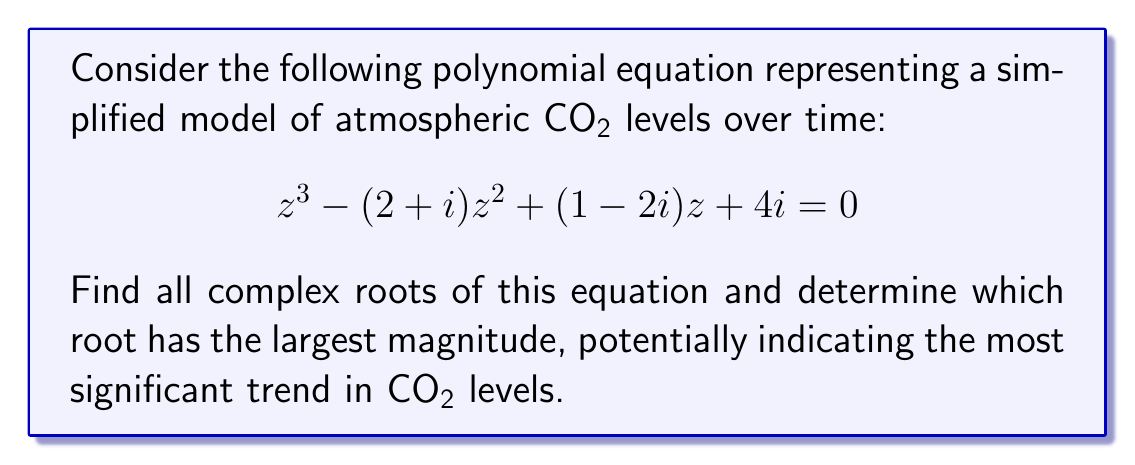Can you solve this math problem? 1) To find the complex roots, we can use the cubic formula or numerical methods. Let's use a numerical method for this problem.

2) Using the Newton-Raphson method or a computer algebra system, we can find the approximate roots:

   $z_1 \approx 1.7071 + 0.2929i$
   $z_2 \approx -0.3536 + 1.3536i$
   $z_3 \approx 0.6464 - 0.6464i$

3) To determine which root has the largest magnitude, we calculate |z| for each root:

   $|z_1| = \sqrt{(1.7071)^2 + (0.2929)^2} \approx 1.7321$
   $|z_2| = \sqrt{(-0.3536)^2 + (1.3536)^2} \approx 1.4142$
   $|z_3| = \sqrt{(0.6464)^2 + (-0.6464)^2} \approx 0.9142$

4) Comparing these magnitudes, we see that $|z_1|$ is the largest.

5) Therefore, the root with the largest magnitude is $z_1 \approx 1.7071 + 0.2929i$.
Answer: $1.7071 + 0.2929i$ 